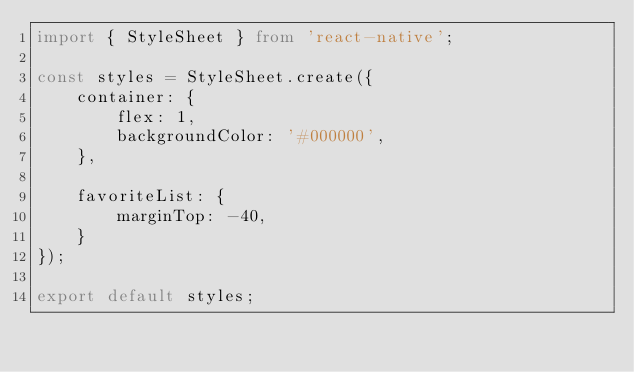<code> <loc_0><loc_0><loc_500><loc_500><_TypeScript_>import { StyleSheet } from 'react-native';

const styles = StyleSheet.create({
    container: {
        flex: 1,
        backgroundColor: '#000000',
    },     
    
    favoriteList: {
        marginTop: -40,
    }
});

export default styles;</code> 